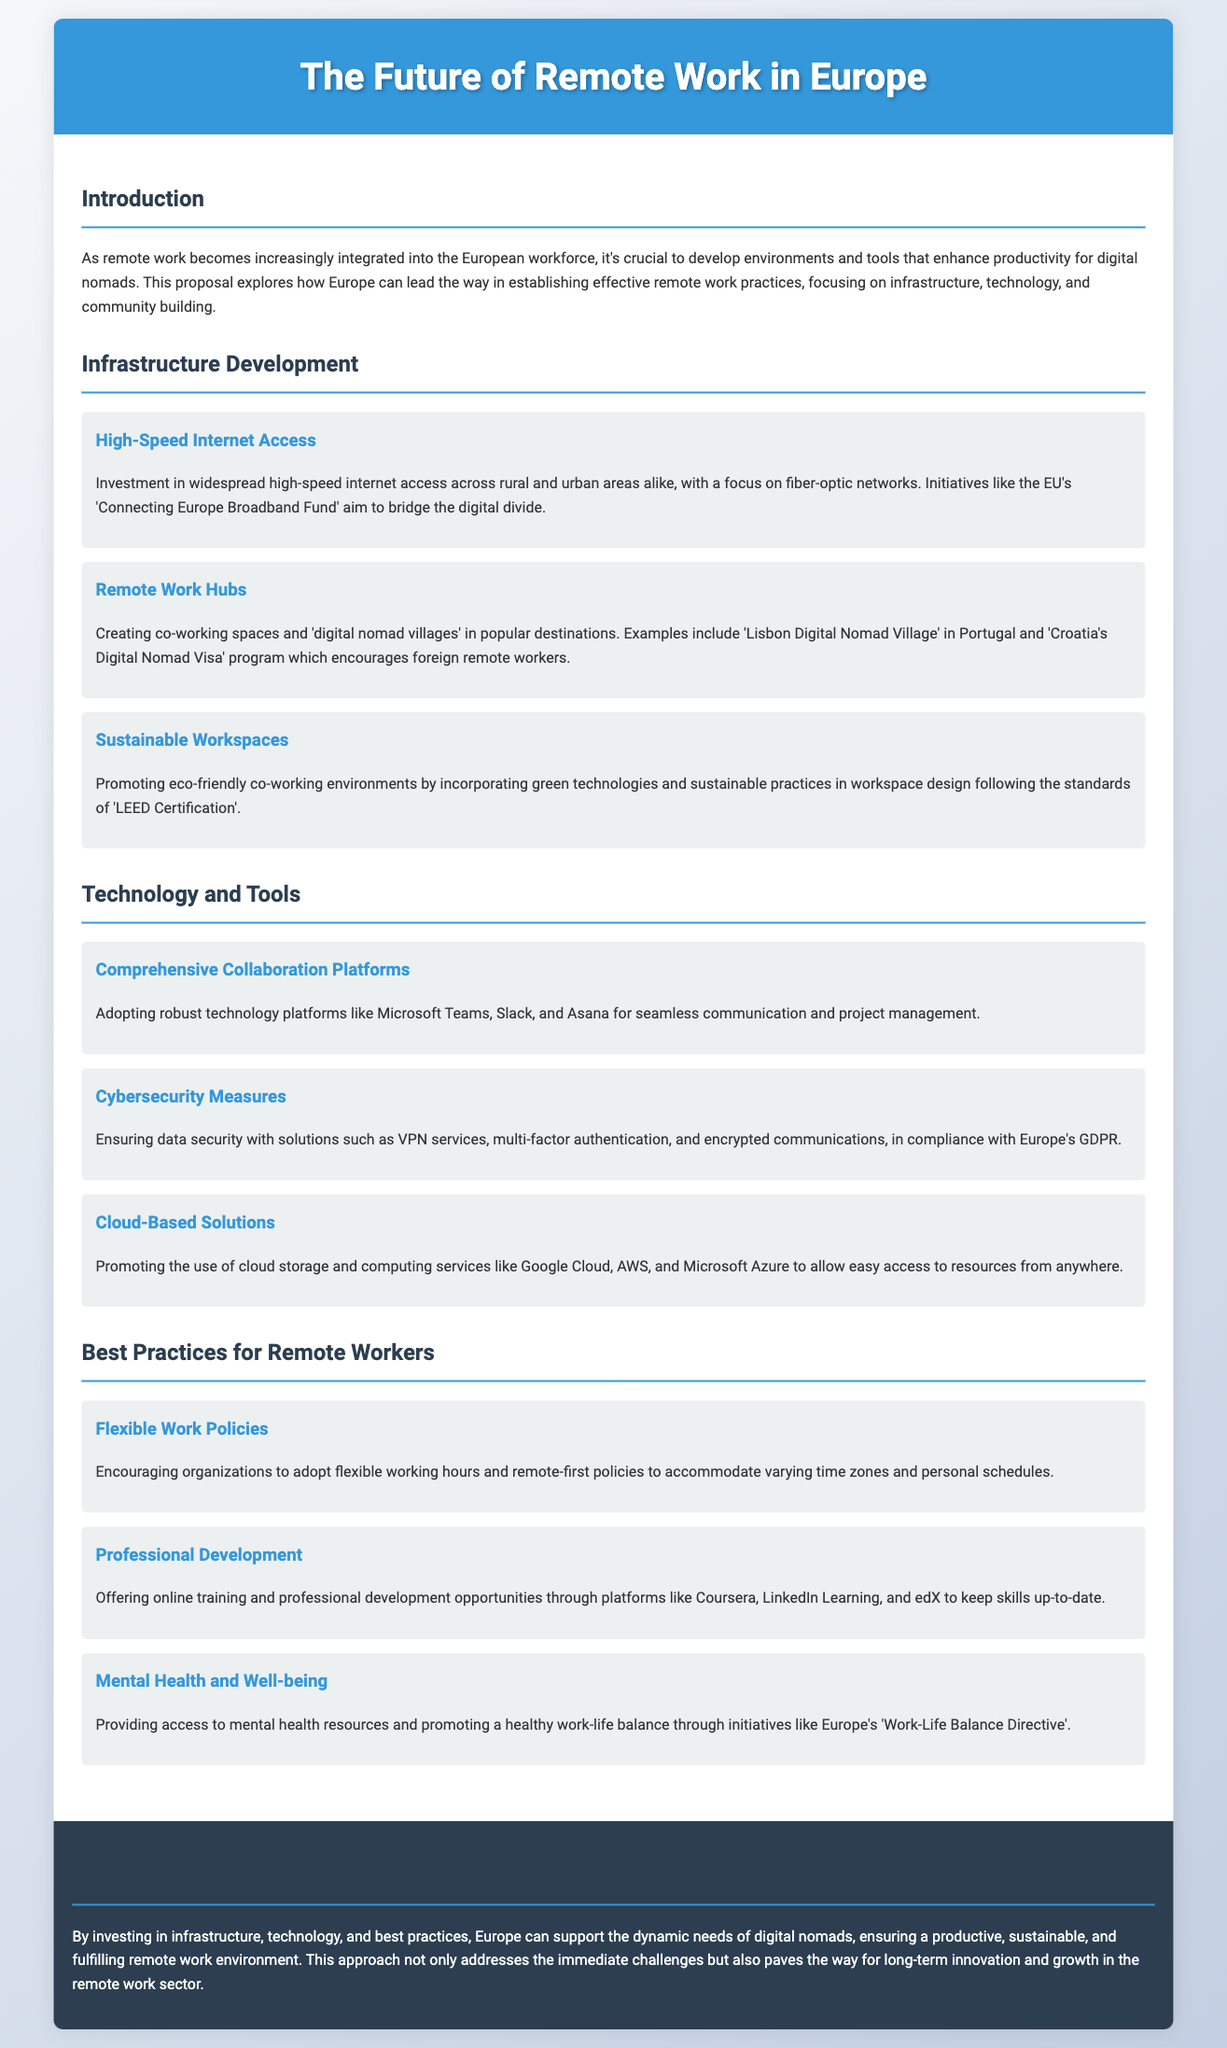What is the focus of the proposal? The proposal focuses on developing environments and tools that enhance productivity for digital nomads.
Answer: productivity for digital nomads What type of spaces are suggested for remote work? The document mentions creating co-working spaces and 'digital nomad villages' as a recommendation.
Answer: co-working spaces and 'digital nomad villages' Which EU initiative aims to bridge the digital divide? The proposal references the 'Connecting Europe Broadband Fund' as an initiative to ensure high-speed internet access.
Answer: Connecting Europe Broadband Fund What are mentioned as crucial cybersecurity measures? Key measures include VPN services, multi-factor authentication, and encrypted communications to ensure data security.
Answer: VPN services, multi-factor authentication, and encrypted communications What is one of the best practices for remote workers? Encouraging organizations to adopt flexible working hours is highlighted as a best practice.
Answer: flexible working hours Which countries are referenced for promoting digital nomadism? The document cites Portugal and Croatia as countries with initiatives for digital nomads.
Answer: Portugal and Croatia What technology platforms are recommended for collaboration? The proposal mentions Microsoft Teams, Slack, and Asana for effective collaboration among remote workers.
Answer: Microsoft Teams, Slack, and Asana What does the proposal suggest for mental health support? It suggests providing access to mental health resources for promoting a healthy work-life balance.
Answer: access to mental health resources What is the main goal of the proposal? The main goal is to support the dynamic needs of digital nomads through investment in various areas.
Answer: support the dynamic needs of digital nomads 